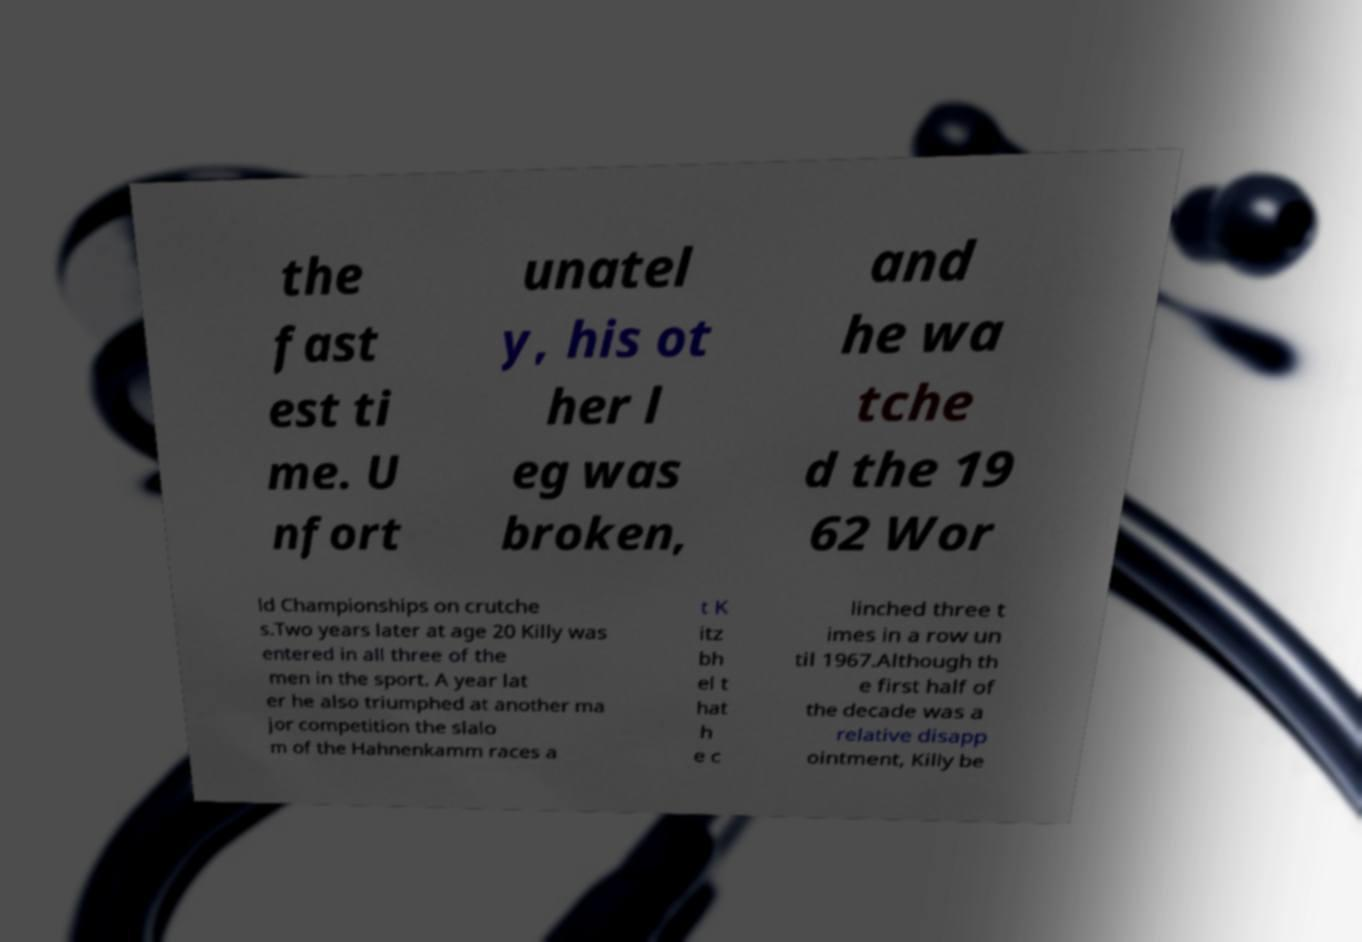For documentation purposes, I need the text within this image transcribed. Could you provide that? the fast est ti me. U nfort unatel y, his ot her l eg was broken, and he wa tche d the 19 62 Wor ld Championships on crutche s.Two years later at age 20 Killy was entered in all three of the men in the sport. A year lat er he also triumphed at another ma jor competition the slalo m of the Hahnenkamm races a t K itz bh el t hat h e c linched three t imes in a row un til 1967.Although th e first half of the decade was a relative disapp ointment, Killy be 